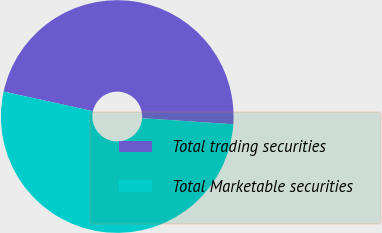<chart> <loc_0><loc_0><loc_500><loc_500><pie_chart><fcel>Total trading securities<fcel>Total Marketable securities<nl><fcel>47.62%<fcel>52.38%<nl></chart> 